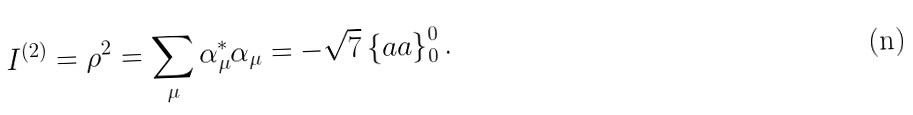<formula> <loc_0><loc_0><loc_500><loc_500>I ^ { ( 2 ) } = \rho ^ { 2 } = \sum _ { \mu } \alpha _ { \mu } ^ { * } \alpha _ { \mu } = - \sqrt { 7 } \left \{ a a \right \} _ { 0 } ^ { 0 } .</formula> 